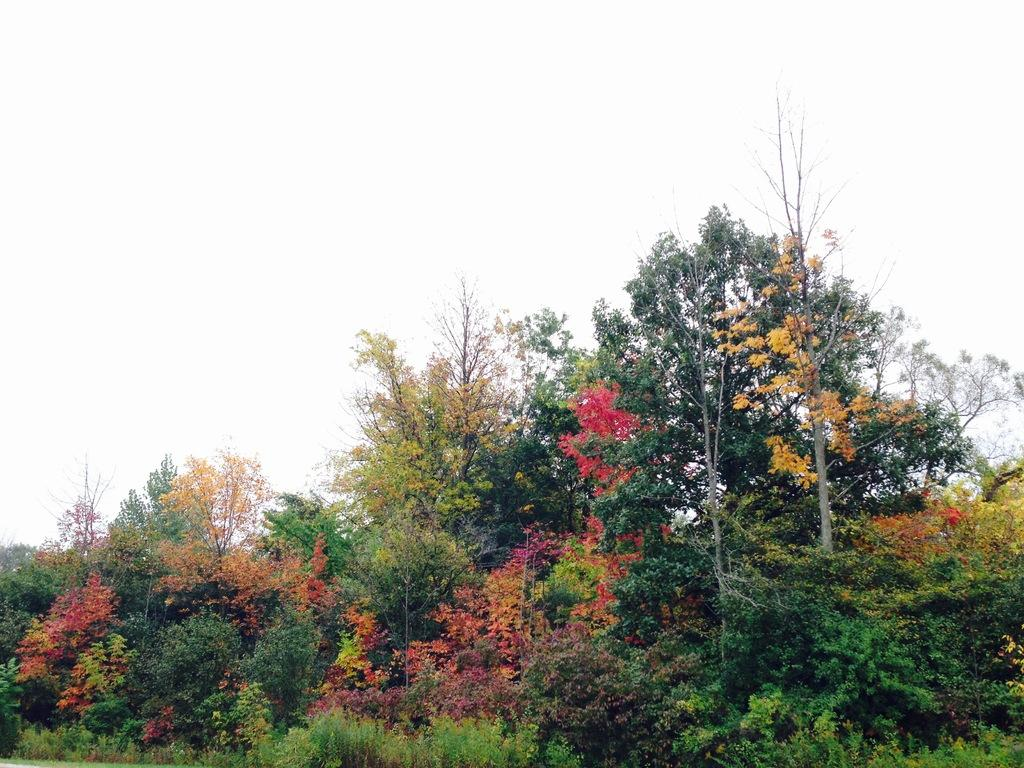What can be seen at the top of the image? The sky is visible towards the top of the image. What type of vegetation is present in the image? There are trees in the image. What other type of vegetation is present near the bottom of the image? There are plants towards the bottom of the image. How many fish are swimming in the birthday party depicted in the image? There are no fish or birthday party present in the image; it features the sky, trees, and plants. 